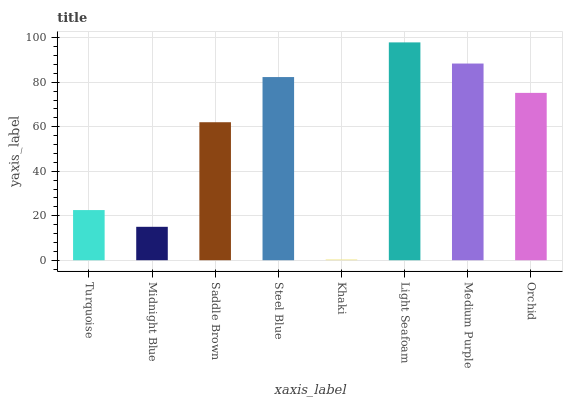Is Khaki the minimum?
Answer yes or no. Yes. Is Light Seafoam the maximum?
Answer yes or no. Yes. Is Midnight Blue the minimum?
Answer yes or no. No. Is Midnight Blue the maximum?
Answer yes or no. No. Is Turquoise greater than Midnight Blue?
Answer yes or no. Yes. Is Midnight Blue less than Turquoise?
Answer yes or no. Yes. Is Midnight Blue greater than Turquoise?
Answer yes or no. No. Is Turquoise less than Midnight Blue?
Answer yes or no. No. Is Orchid the high median?
Answer yes or no. Yes. Is Saddle Brown the low median?
Answer yes or no. Yes. Is Light Seafoam the high median?
Answer yes or no. No. Is Midnight Blue the low median?
Answer yes or no. No. 